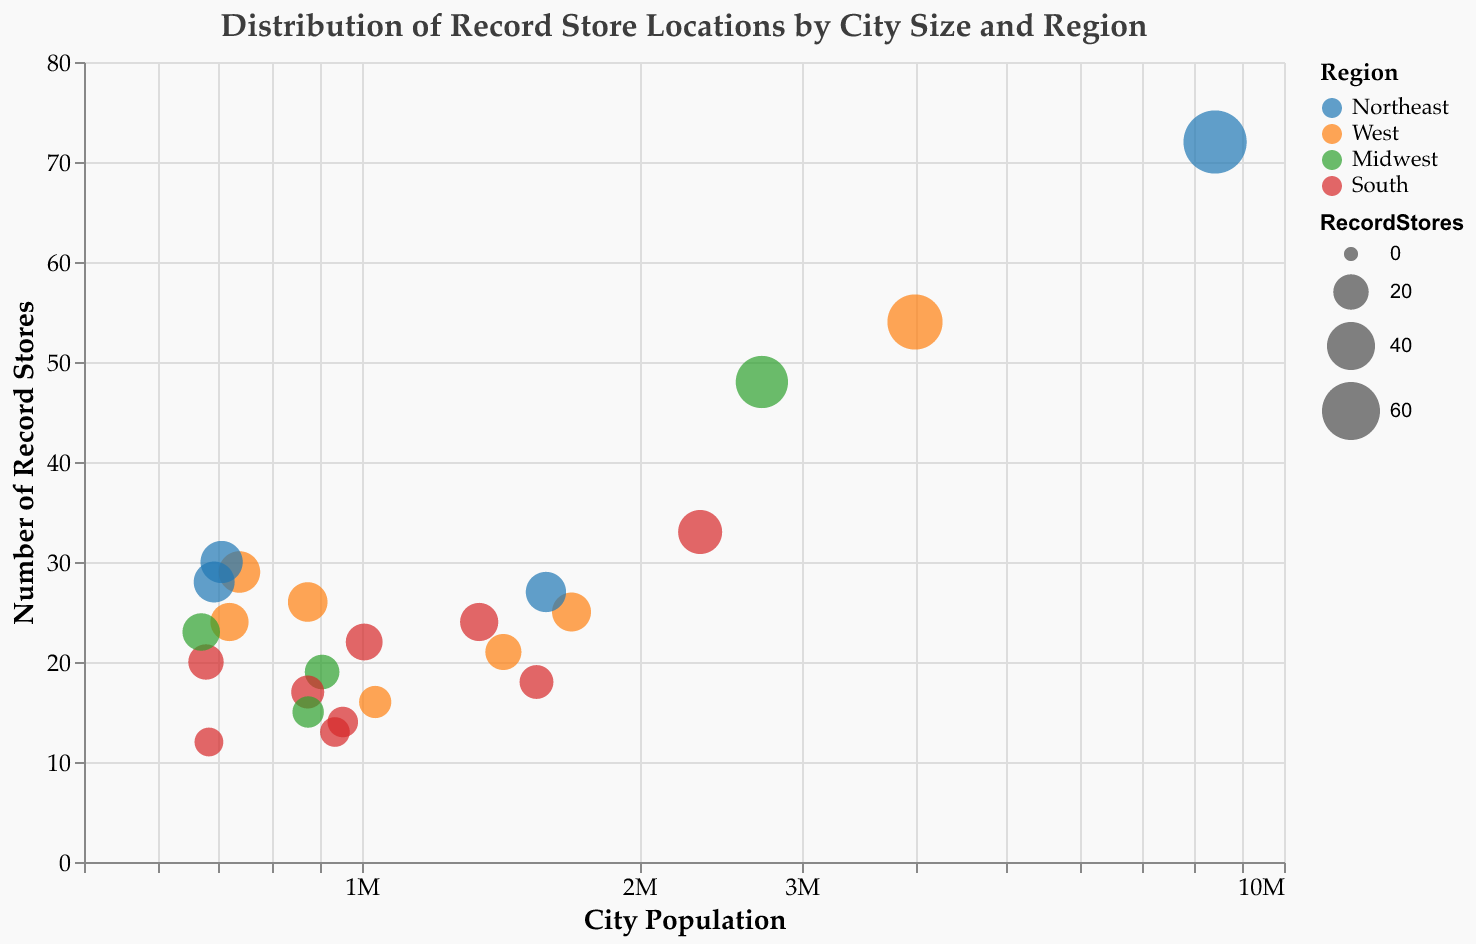What is the title of the figure? The title of the figure can be found at the top, which provides an overview of what the figure is about. It reads "Distribution of Record Store Locations by City Size and Region."
Answer: Distribution of Record Store Locations by City Size and Region Which city has the most record stores? By analyzing the size of the bubbles, the largest bubble corresponds to New York City, which is also highlighted in the tooltip. It has the most record stores.
Answer: New York City How does the population of Los Angeles compare to Chicago? By looking at the x-axis positions of the bubbles, Los Angeles sits further to the right than Chicago, indicating it has a higher population. Specifically, Los Angeles has a population of 3,980,400, while Chicago has 2,716,000.
Answer: Los Angeles has a larger population What is the color representing the Midwest region? The color coding for regions is provided in the legend. The Midwest region is represented by a green color.
Answer: Green Which city in the West region has the third-most record stores? By counting the number of stores for cities in the West region, Los Angeles is first, Seattle is second, and Phoenix is third with 25 stores.
Answer: Phoenix How many record stores are there in total in the Northeast region? Sum up the number of record stores for all cities in the Northeast region: 
(New York City: 72) + (Philadelphia: 27) + (Washington D.C.: 30) + (Boston: 28) = 157.
Answer: 157 Which city has a population under 700,000 but more than 25 record stores? By examining both the x (population) and y (record stores) axes, Washington D.C. fits the criteria with a population of 705,000 and 30 record stores.
Answer: Washington D.C Between Houston and Dallas, which city has more record stores? By comparing the y-axis positions of the bubbles for Houston and Dallas, Houston has more record stores (33) compared to Dallas (24).
Answer: Houston What region shows a consistent pattern between city size and the number of record stores? By examining the overall trend of bubbles colored by region, the Northeast shows a consistent pattern where larger cities tend to have more record stores.
Answer: Northeast Compare the record store density between San Francisco and San Jose. Which city has a higher density? Record store density can be calculated by dividing the number of record stores by the population. For San Francisco: 26/874,000 ≈ 0.0000297, for San Jose: 16/1,034,400 ≈ 0.0000155. San Francisco has a higher density.
Answer: San Francisco 